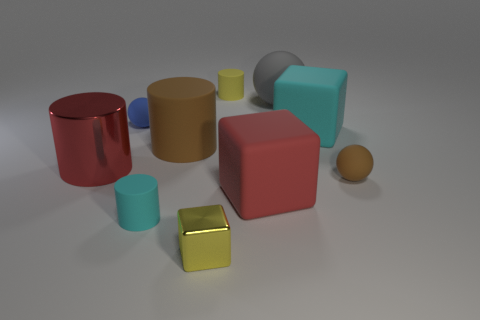What size is the red thing that is on the right side of the yellow matte thing?
Make the answer very short. Large. There is a brown thing that is the same shape as the tiny cyan rubber thing; what is its material?
Give a very brief answer. Rubber. What shape is the tiny matte object that is to the left of the small cyan rubber cylinder?
Offer a very short reply. Sphere. What number of small cyan matte things are the same shape as the red metal thing?
Offer a terse response. 1. Are there an equal number of shiny cylinders that are on the right side of the large cyan cube and big red shiny cylinders in front of the red shiny cylinder?
Your response must be concise. Yes. Are there any large brown cylinders made of the same material as the big ball?
Your answer should be compact. Yes. Is the tiny blue object made of the same material as the large brown thing?
Give a very brief answer. Yes. How many brown things are either shiny things or large shiny things?
Your answer should be very brief. 0. Is the number of tiny blue rubber balls that are behind the large metallic cylinder greater than the number of purple matte cubes?
Your response must be concise. Yes. Is there a thing that has the same color as the small block?
Offer a terse response. Yes. 